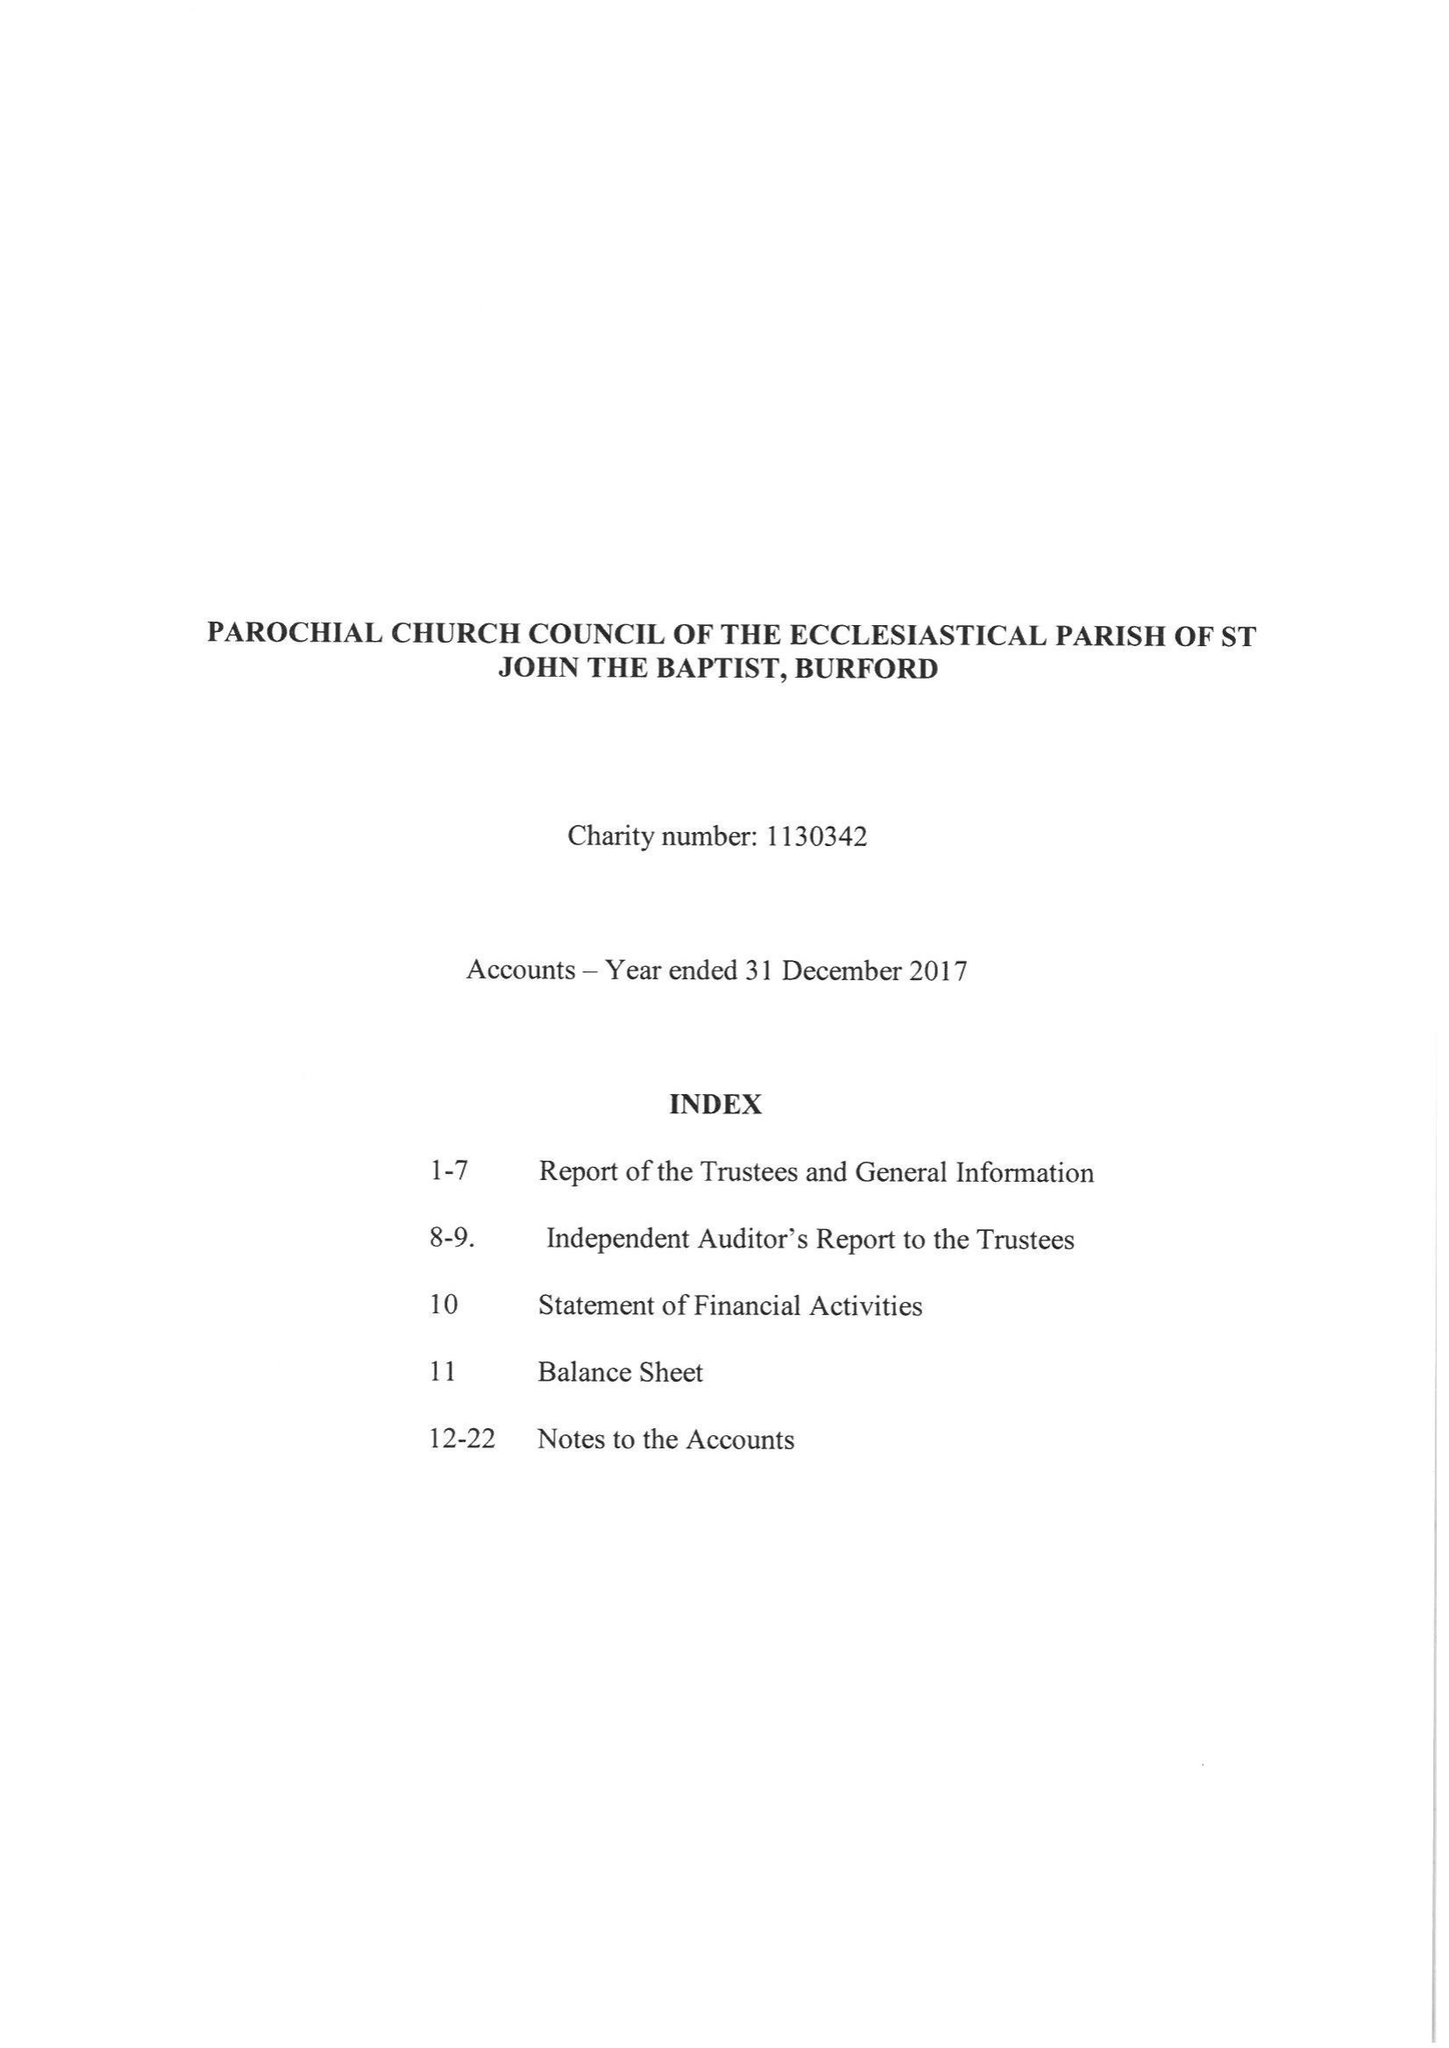What is the value for the address__postcode?
Answer the question using a single word or phrase. OX18 4RZ 